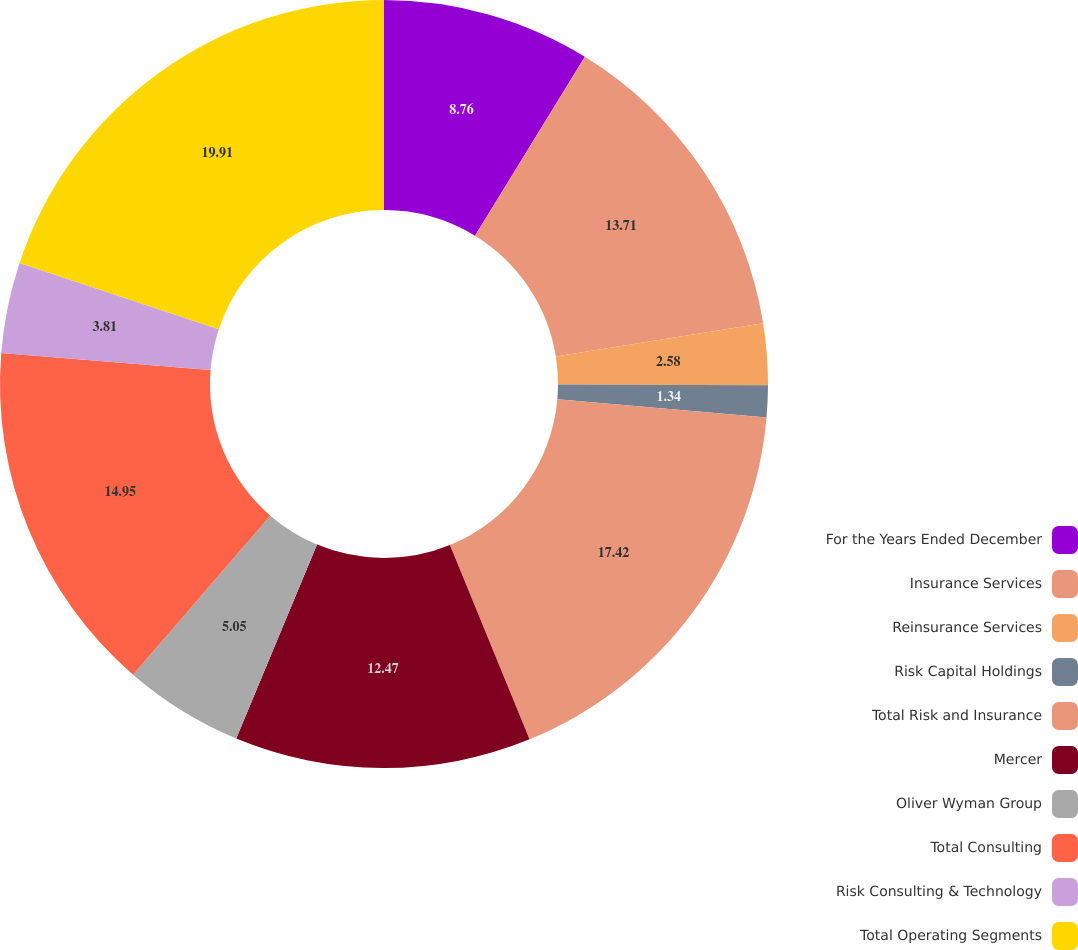Convert chart to OTSL. <chart><loc_0><loc_0><loc_500><loc_500><pie_chart><fcel>For the Years Ended December<fcel>Insurance Services<fcel>Reinsurance Services<fcel>Risk Capital Holdings<fcel>Total Risk and Insurance<fcel>Mercer<fcel>Oliver Wyman Group<fcel>Total Consulting<fcel>Risk Consulting & Technology<fcel>Total Operating Segments<nl><fcel>8.76%<fcel>13.71%<fcel>2.58%<fcel>1.34%<fcel>17.42%<fcel>12.47%<fcel>5.05%<fcel>14.95%<fcel>3.81%<fcel>19.9%<nl></chart> 